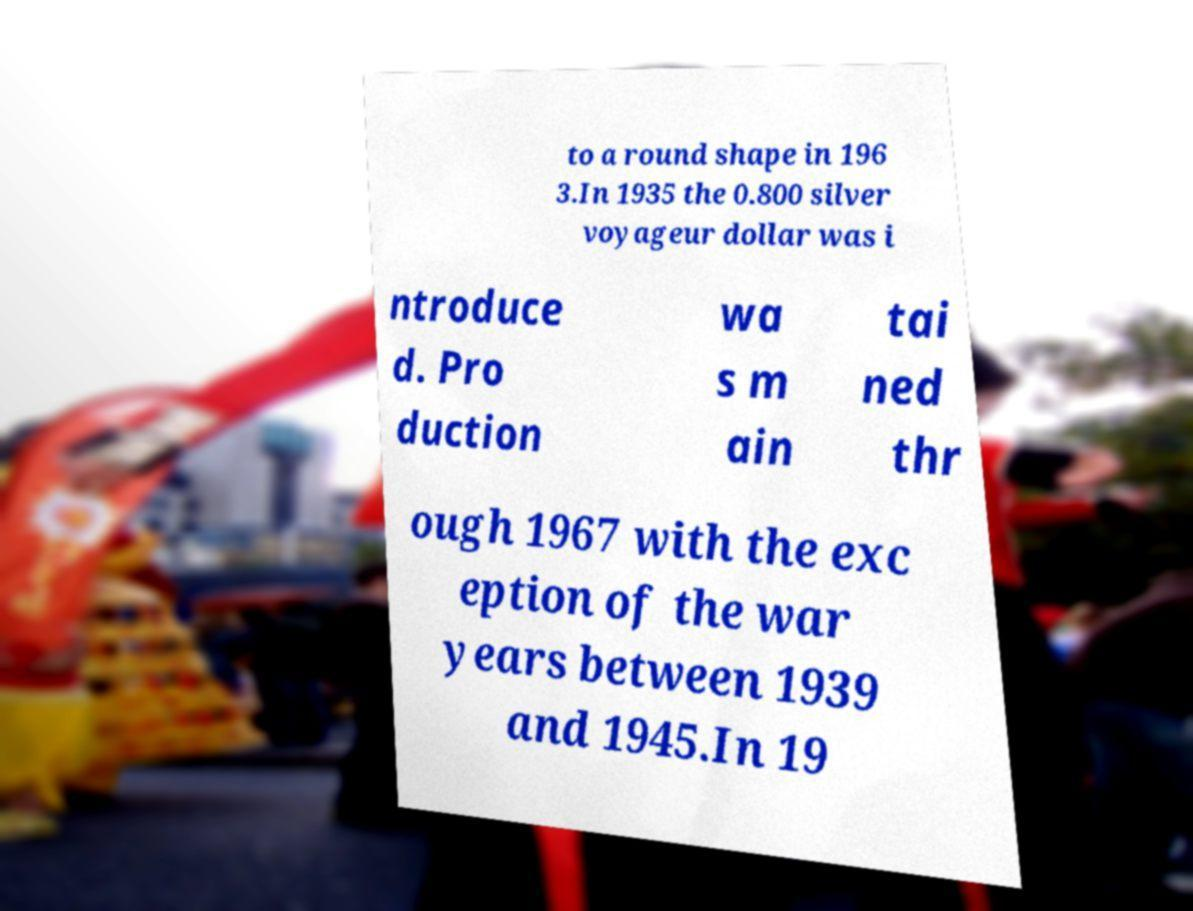What messages or text are displayed in this image? I need them in a readable, typed format. to a round shape in 196 3.In 1935 the 0.800 silver voyageur dollar was i ntroduce d. Pro duction wa s m ain tai ned thr ough 1967 with the exc eption of the war years between 1939 and 1945.In 19 